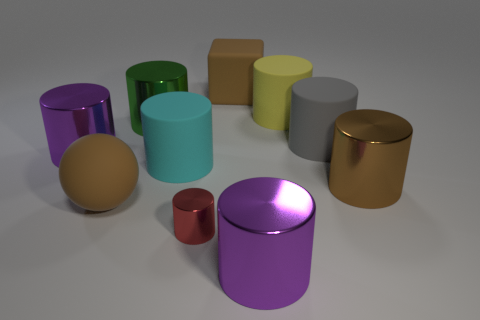Subtract all purple shiny cylinders. How many cylinders are left? 6 Subtract 5 cylinders. How many cylinders are left? 3 Subtract all purple cylinders. How many cylinders are left? 6 Subtract all purple cylinders. Subtract all cyan spheres. How many cylinders are left? 6 Subtract all spheres. How many objects are left? 9 Subtract 0 green blocks. How many objects are left? 10 Subtract all big purple metal cylinders. Subtract all rubber balls. How many objects are left? 7 Add 9 small cylinders. How many small cylinders are left? 10 Add 7 gray rubber cubes. How many gray rubber cubes exist? 7 